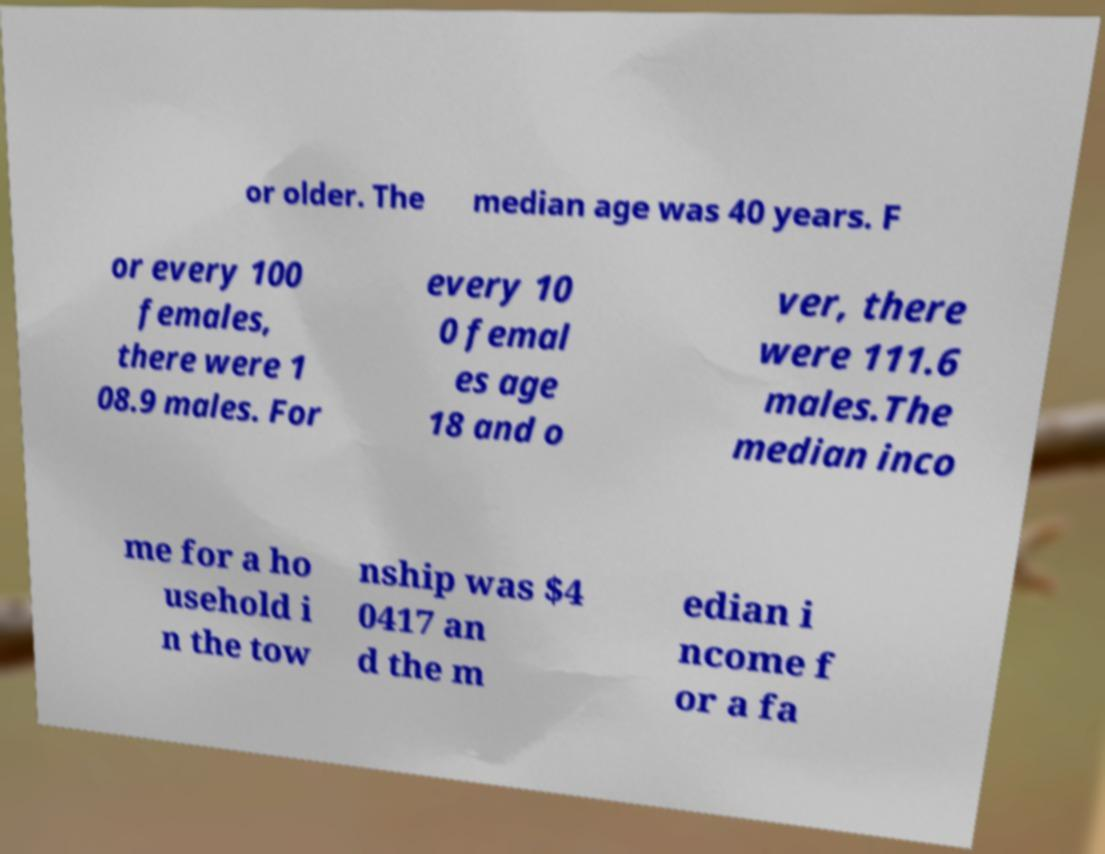What messages or text are displayed in this image? I need them in a readable, typed format. or older. The median age was 40 years. F or every 100 females, there were 1 08.9 males. For every 10 0 femal es age 18 and o ver, there were 111.6 males.The median inco me for a ho usehold i n the tow nship was $4 0417 an d the m edian i ncome f or a fa 